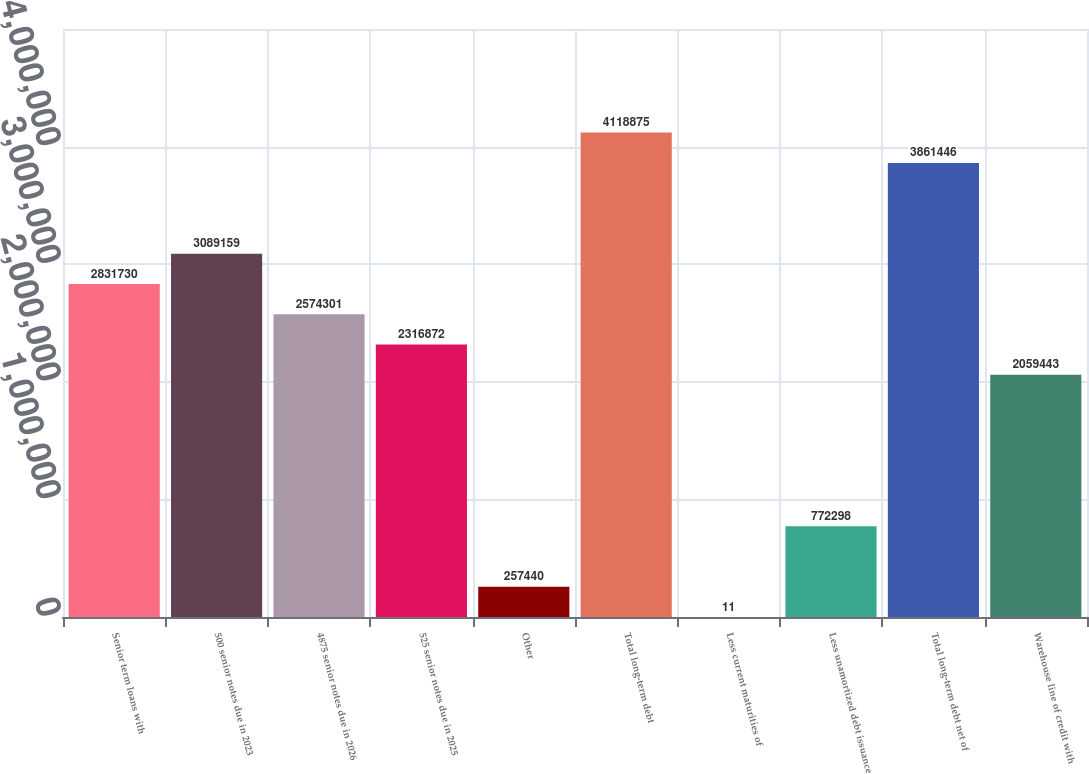<chart> <loc_0><loc_0><loc_500><loc_500><bar_chart><fcel>Senior term loans with<fcel>500 senior notes due in 2023<fcel>4875 senior notes due in 2026<fcel>525 senior notes due in 2025<fcel>Other<fcel>Total long-term debt<fcel>Less current maturities of<fcel>Less unamortized debt issuance<fcel>Total long-term debt net of<fcel>Warehouse line of credit with<nl><fcel>2.83173e+06<fcel>3.08916e+06<fcel>2.5743e+06<fcel>2.31687e+06<fcel>257440<fcel>4.11888e+06<fcel>11<fcel>772298<fcel>3.86145e+06<fcel>2.05944e+06<nl></chart> 